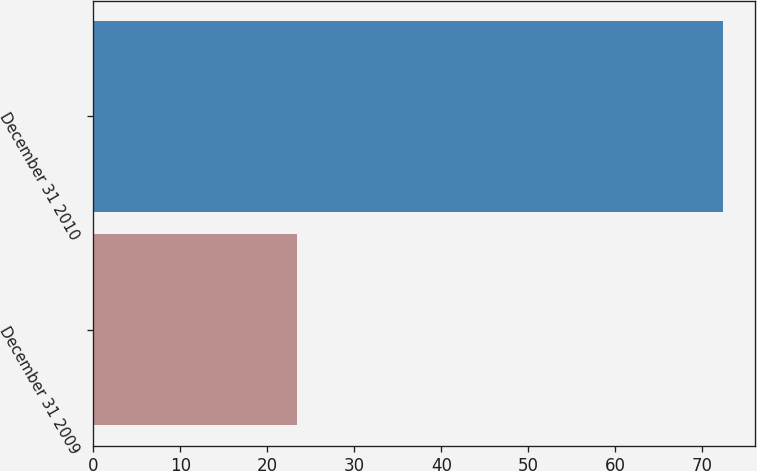<chart> <loc_0><loc_0><loc_500><loc_500><bar_chart><fcel>December 31 2009<fcel>December 31 2010<nl><fcel>23.4<fcel>72.4<nl></chart> 